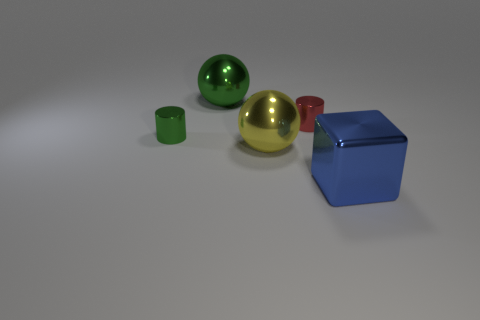Add 1 cubes. How many objects exist? 6 Subtract all cylinders. How many objects are left? 3 Subtract 1 blocks. How many blocks are left? 0 Subtract all big gray rubber cylinders. Subtract all small shiny objects. How many objects are left? 3 Add 3 big yellow metal spheres. How many big yellow metal spheres are left? 4 Add 5 large blue metallic cylinders. How many large blue metallic cylinders exist? 5 Subtract 0 red cubes. How many objects are left? 5 Subtract all gray spheres. Subtract all cyan cylinders. How many spheres are left? 2 